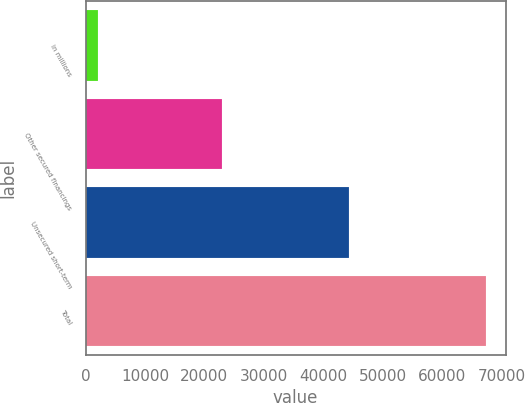Convert chart to OTSL. <chart><loc_0><loc_0><loc_500><loc_500><bar_chart><fcel>in millions<fcel>Other secured financings<fcel>Unsecured short-term<fcel>Total<nl><fcel>2012<fcel>23045<fcel>44304<fcel>67349<nl></chart> 